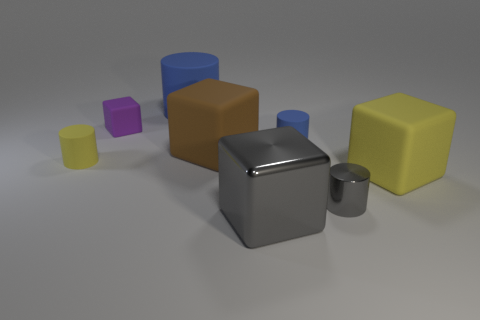What number of cyan things are either large shiny cubes or big rubber blocks?
Provide a succinct answer. 0. What is the yellow thing on the left side of the yellow thing that is to the right of the gray block made of?
Your answer should be very brief. Rubber. Do the large blue object and the small blue matte object have the same shape?
Provide a short and direct response. Yes. The rubber block that is the same size as the yellow cylinder is what color?
Your answer should be very brief. Purple. Is there a tiny cylinder that has the same color as the large cylinder?
Make the answer very short. Yes. Are any large green matte cubes visible?
Provide a short and direct response. No. Are the big block that is on the left side of the big metal block and the purple object made of the same material?
Your answer should be very brief. Yes. The matte thing that is the same color as the big cylinder is what size?
Ensure brevity in your answer.  Small. How many other brown matte cubes have the same size as the brown cube?
Ensure brevity in your answer.  0. Is the number of tiny blue cylinders that are in front of the gray cube the same as the number of small cyan metallic cubes?
Give a very brief answer. Yes. 